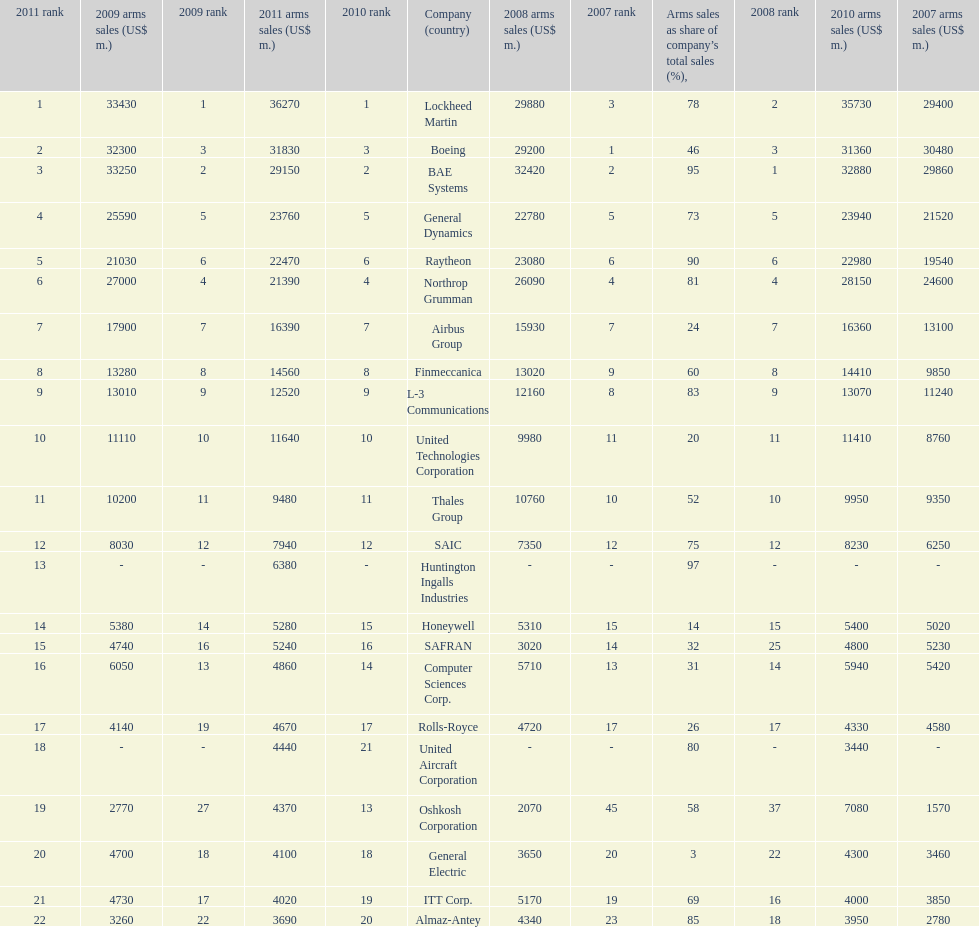Which company had the highest 2009 arms sales? Lockheed Martin. 